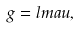Convert formula to latex. <formula><loc_0><loc_0><loc_500><loc_500>g = l m a u ,</formula> 